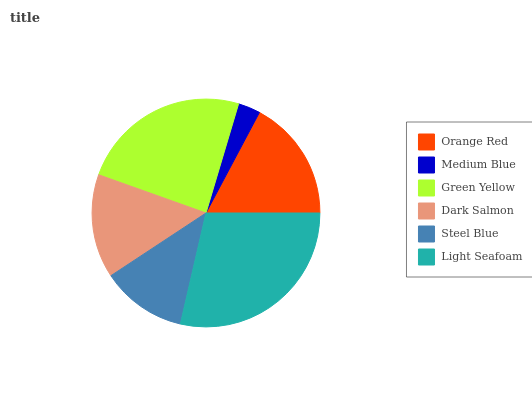Is Medium Blue the minimum?
Answer yes or no. Yes. Is Light Seafoam the maximum?
Answer yes or no. Yes. Is Green Yellow the minimum?
Answer yes or no. No. Is Green Yellow the maximum?
Answer yes or no. No. Is Green Yellow greater than Medium Blue?
Answer yes or no. Yes. Is Medium Blue less than Green Yellow?
Answer yes or no. Yes. Is Medium Blue greater than Green Yellow?
Answer yes or no. No. Is Green Yellow less than Medium Blue?
Answer yes or no. No. Is Orange Red the high median?
Answer yes or no. Yes. Is Dark Salmon the low median?
Answer yes or no. Yes. Is Green Yellow the high median?
Answer yes or no. No. Is Orange Red the low median?
Answer yes or no. No. 